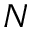<formula> <loc_0><loc_0><loc_500><loc_500>N</formula> 